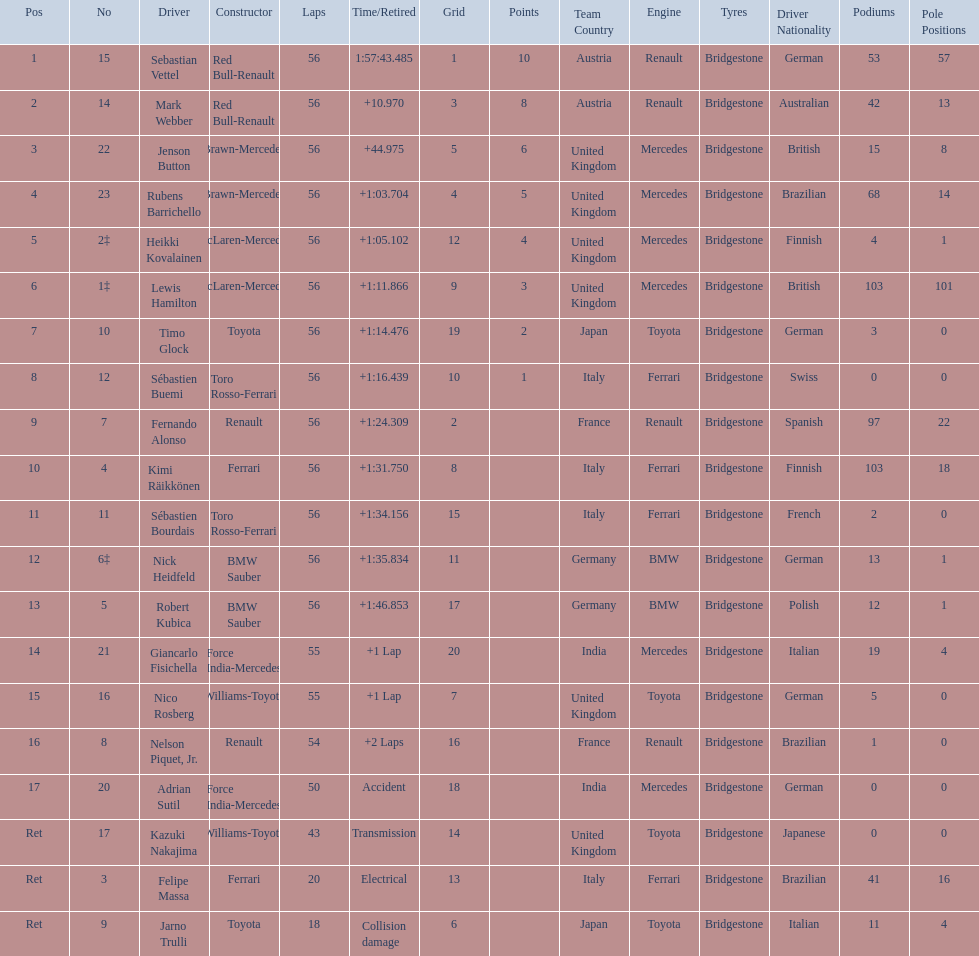Which drivers took part in the 2009 chinese grand prix? Sebastian Vettel, Mark Webber, Jenson Button, Rubens Barrichello, Heikki Kovalainen, Lewis Hamilton, Timo Glock, Sébastien Buemi, Fernando Alonso, Kimi Räikkönen, Sébastien Bourdais, Nick Heidfeld, Robert Kubica, Giancarlo Fisichella, Nico Rosberg, Nelson Piquet, Jr., Adrian Sutil, Kazuki Nakajima, Felipe Massa, Jarno Trulli. Of these, who completed all 56 laps? Sebastian Vettel, Mark Webber, Jenson Button, Rubens Barrichello, Heikki Kovalainen, Lewis Hamilton, Timo Glock, Sébastien Buemi, Fernando Alonso, Kimi Räikkönen, Sébastien Bourdais, Nick Heidfeld, Robert Kubica. Of these, which did ferrari not participate as a constructor? Sebastian Vettel, Mark Webber, Jenson Button, Rubens Barrichello, Heikki Kovalainen, Lewis Hamilton, Timo Glock, Fernando Alonso, Kimi Räikkönen, Nick Heidfeld, Robert Kubica. Of the remaining, which is in pos 1? Sebastian Vettel. 